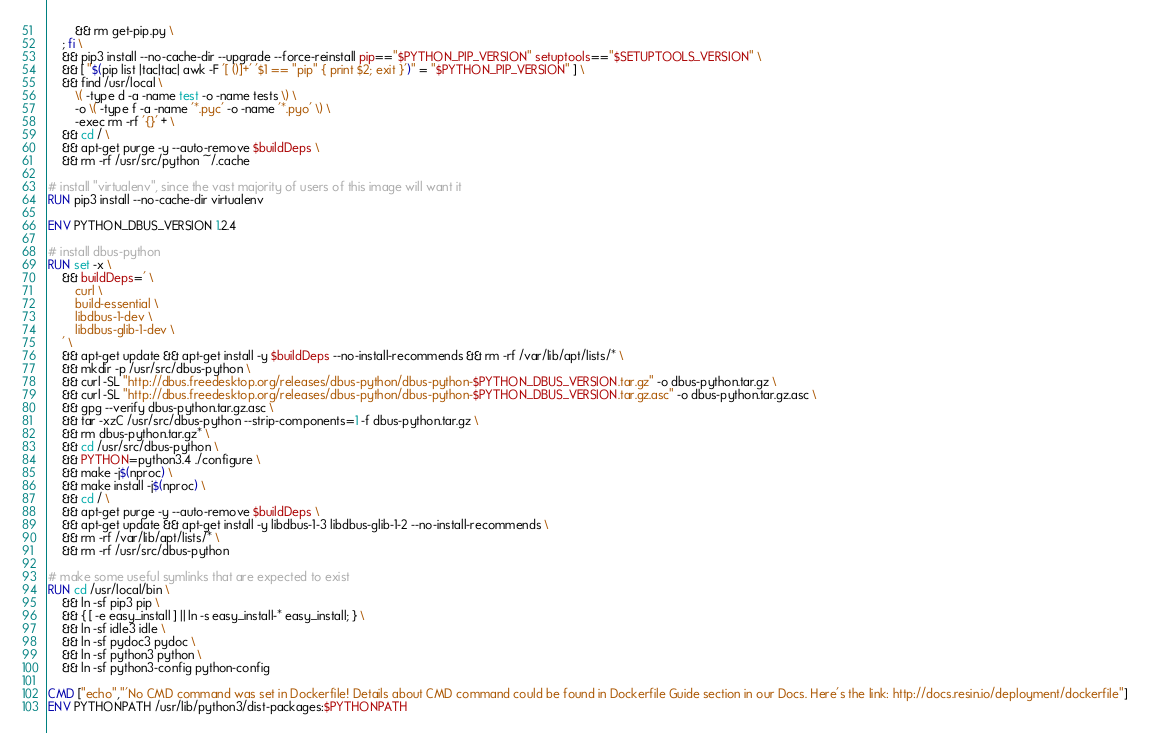Convert code to text. <code><loc_0><loc_0><loc_500><loc_500><_Dockerfile_>		&& rm get-pip.py \
	; fi \
	&& pip3 install --no-cache-dir --upgrade --force-reinstall pip=="$PYTHON_PIP_VERSION" setuptools=="$SETUPTOOLS_VERSION" \
	&& [ "$(pip list |tac|tac| awk -F '[ ()]+' '$1 == "pip" { print $2; exit }')" = "$PYTHON_PIP_VERSION" ] \
	&& find /usr/local \
		\( -type d -a -name test -o -name tests \) \
		-o \( -type f -a -name '*.pyc' -o -name '*.pyo' \) \
		-exec rm -rf '{}' + \
	&& cd / \
	&& apt-get purge -y --auto-remove $buildDeps \
	&& rm -rf /usr/src/python ~/.cache

# install "virtualenv", since the vast majority of users of this image will want it
RUN pip3 install --no-cache-dir virtualenv

ENV PYTHON_DBUS_VERSION 1.2.4

# install dbus-python
RUN set -x \
	&& buildDeps=' \
		curl \
		build-essential \
		libdbus-1-dev \
		libdbus-glib-1-dev \
	' \
	&& apt-get update && apt-get install -y $buildDeps --no-install-recommends && rm -rf /var/lib/apt/lists/* \
	&& mkdir -p /usr/src/dbus-python \
	&& curl -SL "http://dbus.freedesktop.org/releases/dbus-python/dbus-python-$PYTHON_DBUS_VERSION.tar.gz" -o dbus-python.tar.gz \
	&& curl -SL "http://dbus.freedesktop.org/releases/dbus-python/dbus-python-$PYTHON_DBUS_VERSION.tar.gz.asc" -o dbus-python.tar.gz.asc \
	&& gpg --verify dbus-python.tar.gz.asc \
	&& tar -xzC /usr/src/dbus-python --strip-components=1 -f dbus-python.tar.gz \
	&& rm dbus-python.tar.gz* \
	&& cd /usr/src/dbus-python \
	&& PYTHON=python3.4 ./configure \
	&& make -j$(nproc) \
	&& make install -j$(nproc) \
	&& cd / \
	&& apt-get purge -y --auto-remove $buildDeps \
	&& apt-get update && apt-get install -y libdbus-1-3 libdbus-glib-1-2 --no-install-recommends \
	&& rm -rf /var/lib/apt/lists/* \
	&& rm -rf /usr/src/dbus-python

# make some useful symlinks that are expected to exist
RUN cd /usr/local/bin \
	&& ln -sf pip3 pip \
	&& { [ -e easy_install ] || ln -s easy_install-* easy_install; } \
	&& ln -sf idle3 idle \
	&& ln -sf pydoc3 pydoc \
	&& ln -sf python3 python \
	&& ln -sf python3-config python-config

CMD ["echo","'No CMD command was set in Dockerfile! Details about CMD command could be found in Dockerfile Guide section in our Docs. Here's the link: http://docs.resin.io/deployment/dockerfile"]
ENV PYTHONPATH /usr/lib/python3/dist-packages:$PYTHONPATH
</code> 